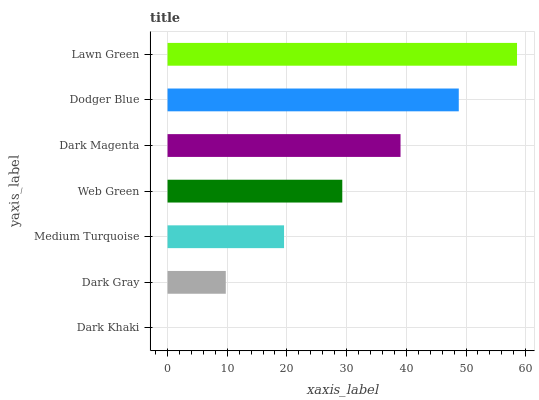Is Dark Khaki the minimum?
Answer yes or no. Yes. Is Lawn Green the maximum?
Answer yes or no. Yes. Is Dark Gray the minimum?
Answer yes or no. No. Is Dark Gray the maximum?
Answer yes or no. No. Is Dark Gray greater than Dark Khaki?
Answer yes or no. Yes. Is Dark Khaki less than Dark Gray?
Answer yes or no. Yes. Is Dark Khaki greater than Dark Gray?
Answer yes or no. No. Is Dark Gray less than Dark Khaki?
Answer yes or no. No. Is Web Green the high median?
Answer yes or no. Yes. Is Web Green the low median?
Answer yes or no. Yes. Is Dodger Blue the high median?
Answer yes or no. No. Is Medium Turquoise the low median?
Answer yes or no. No. 